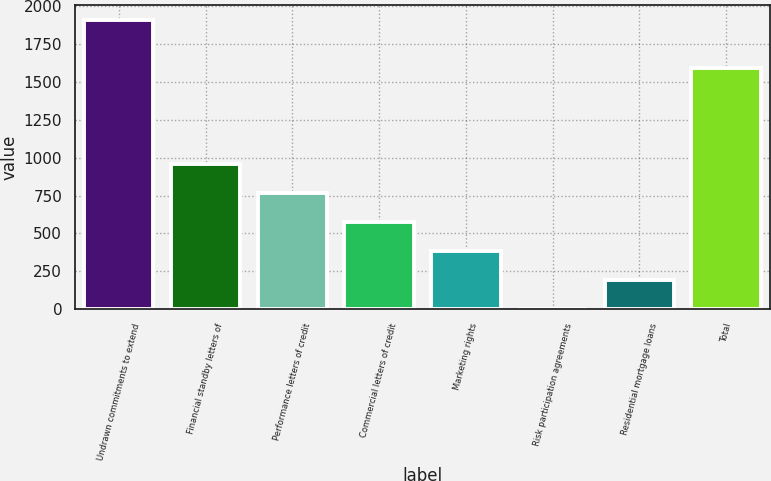Convert chart to OTSL. <chart><loc_0><loc_0><loc_500><loc_500><bar_chart><fcel>Undrawn commitments to extend<fcel>Financial standby letters of<fcel>Performance letters of credit<fcel>Commercial letters of credit<fcel>Marketing rights<fcel>Risk participation agreements<fcel>Residential mortgage loans<fcel>Total<nl><fcel>1912<fcel>957<fcel>766<fcel>575<fcel>384<fcel>2<fcel>193<fcel>1595<nl></chart> 